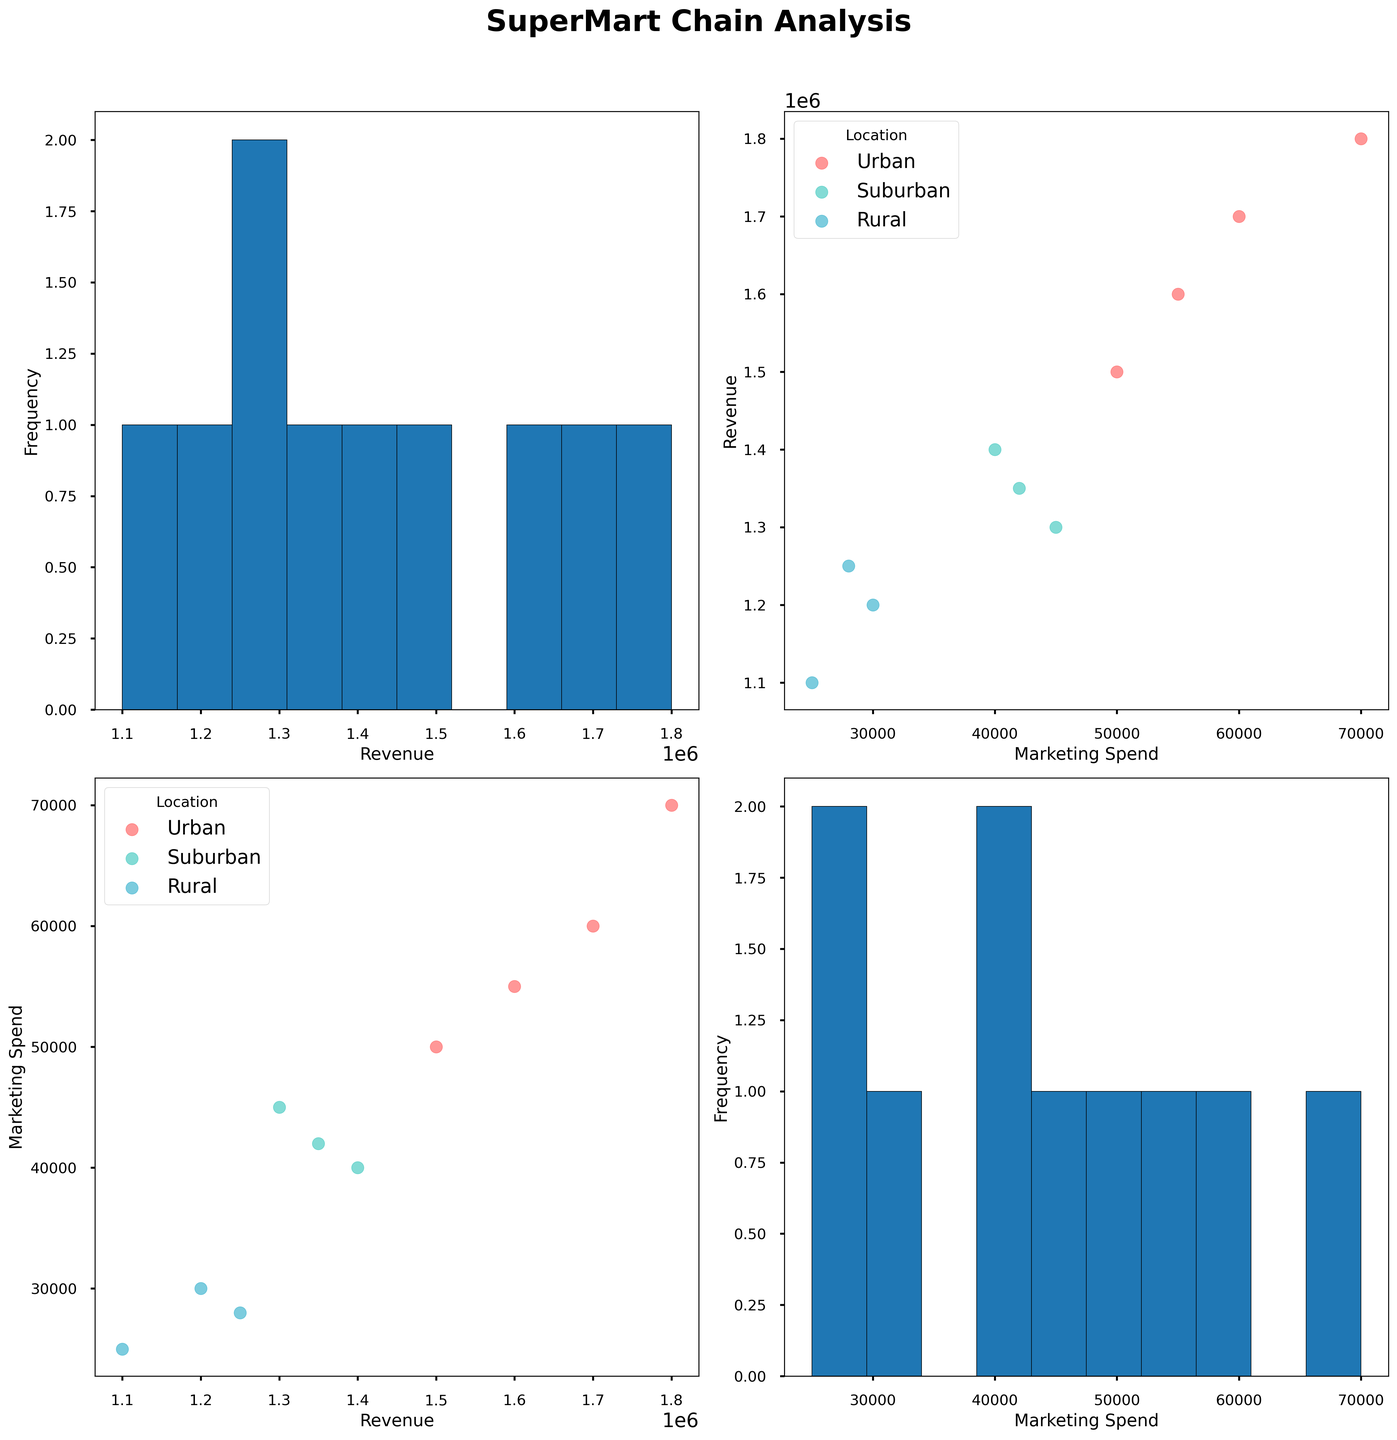What is the color used for Urban locations in the scatter plot matrix? The color used for Urban locations corresponds to a reddish-brown shade in the legend of the scatter plot matrix (marked as '#FF6B6B').
Answer: Reddish-brown Which location shows the highest revenue recorded in the scatter plot matrix? By examining the scatter plot matrix, the highest revenue recorded is observed for an Urban location.
Answer: Urban What is the axis label for the histogram in the top-left quadrant of the scatter plot matrix? In the top-left quadrant, the histogram represents the frequency distribution of the 'Revenue' column, with 'Revenue' as the x-axis label and 'Frequency' as the y-axis label.
Answer: Revenue and Frequency What is the trend between Marketing Spend and Revenue for Suburban locations? Suburban locations show a positive trend between Marketing Spend and Revenue; as the Marketing Spend increases, Revenue also tends to increase.
Answer: Positive Trend How do Rural locations compare in terms of Marketing Spend versus Revenue? When comparing Marketing Spend versus Revenue for Rural locations in the scatter plot matrix, Rural locations are generally grouped with lower Marketing Spend and lower Revenue values.
Answer: Lower values Which plot helps identify the distribution pattern of the 'Marketing Spend' column? The diagonal element in the bottom-right quadrant (bottom row, rightmost column) of the scatter plot matrix shows a histogram that identifies the distribution pattern of the 'Marketing Spend' column.
Answer: Bottom-right quadrant In terms of Revenue, which location generally spends the most on Marketing and how do their revenues compare? Urban locations generally have the highest Marketing Spend, and they also correspondingly have higher Revenues compared to Suburban and Rural locations.
Answer: Urban Are there any overlapping data points between locations in the plot of Marketing Spend versus Revenue? In the scatter plots of Marketing Spend versus Revenue, there are some overlapping data points between Suburban and Urban locations, as indicated by the points sharing similar coordinates.
Answer: Yes What visualization is used to represent each individual data point in the scatter plots? Each individual data point in the scatter plots is represented by a scatter point/dot.
Answer: Scatter point Can you identify which location has the widest range of Marketing Spend values? Urban locations exhibit the widest range of Marketing Spend values, as seen by their spread in the scatter plots.
Answer: Urban 